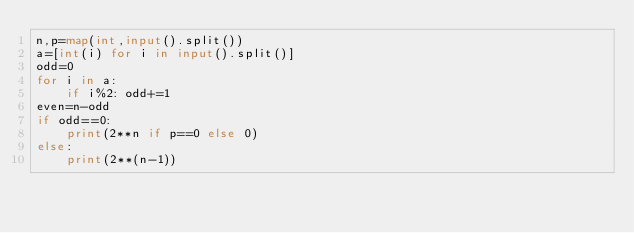<code> <loc_0><loc_0><loc_500><loc_500><_Python_>n,p=map(int,input().split())
a=[int(i) for i in input().split()]
odd=0
for i in a:
    if i%2: odd+=1
even=n-odd
if odd==0:
    print(2**n if p==0 else 0)
else:
    print(2**(n-1))
</code> 